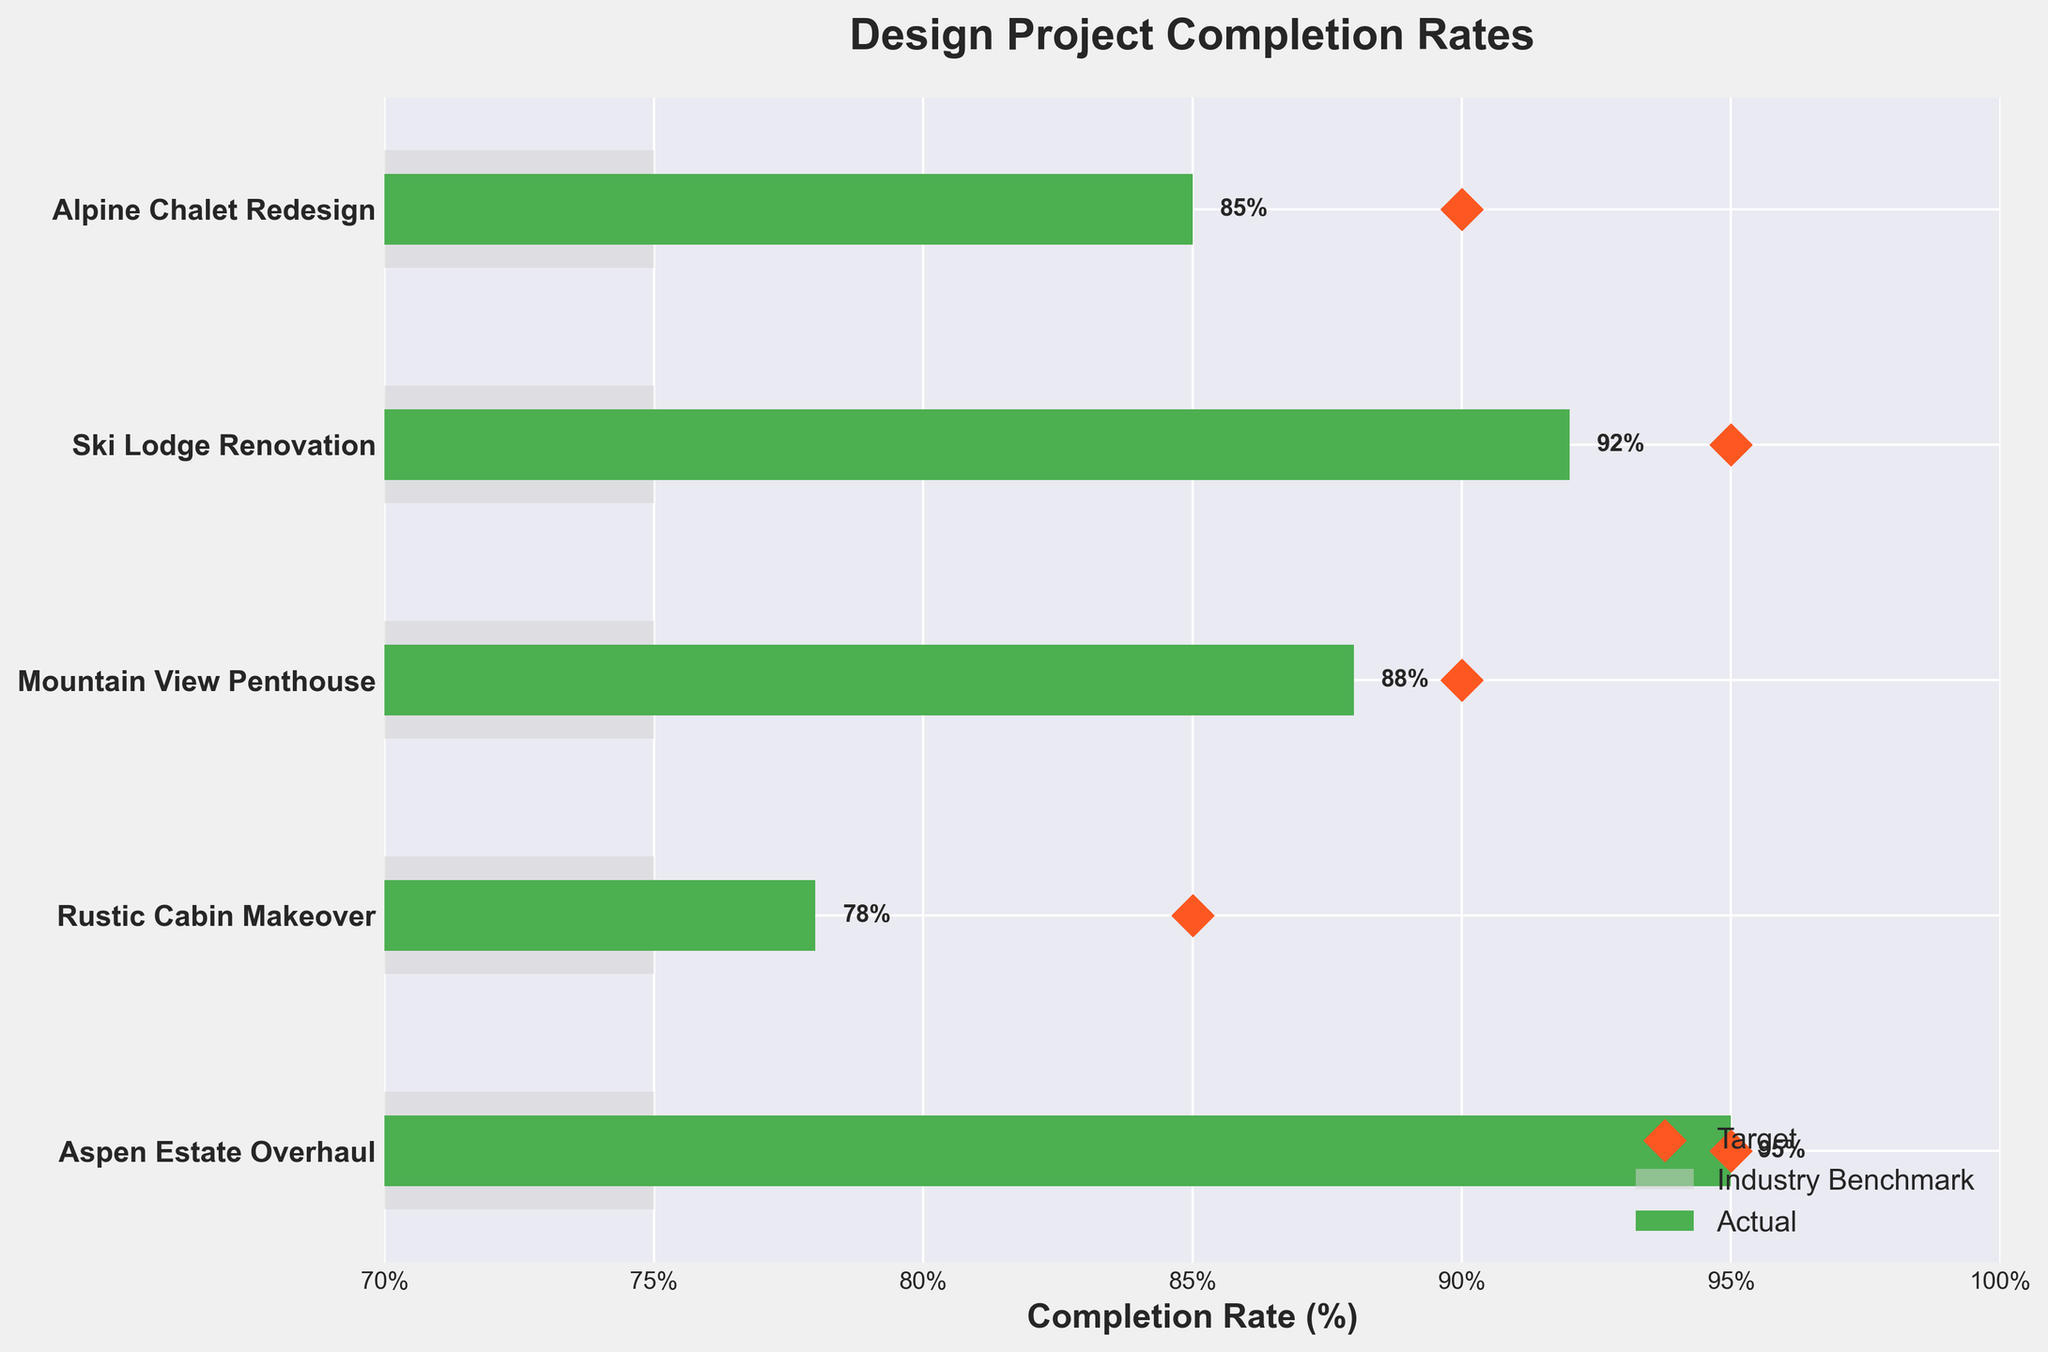What is the completion rate for the "Ski Lodge Renovation" project? The "Ski Lodge Renovation" project’s completion rate can be found from the actual values. Look for the bar corresponding to "Ski Lodge Renovation" and note its value on the x-axis.
Answer: 92% What is the target completion rate for the "Rustic Cabin Makeover" project? The target completion rates are represented by the diamond markers in the figure. Find the diamond associated with the "Rustic Cabin Makeover" project and observe its value on the x-axis.
Answer: 85% Which project has the lowest actual completion rate? To determine the project with the lowest actual completion rate, identify the shortest green bar among all the projects.
Answer: Rustic Cabin Makeover Out of the five projects, how many exceeded the industry benchmark? Compare the lengths of the green bars (actual completion rates) to the light gray bars (industry benchmarks) for each project. Count how many green bars are longer than the light gray bars.
Answer: 5 What is the difference between the actual and target completion rates for the "Mountain View Penthouse" project? Identify the actual and target values for "Mountain View Penthouse". Subtract the actual value from the target value.
Answer: 2% Which project met its target completion rate exactly? Look for a project where the diamond marker (target) aligns perfectly with the end of the green bar (actual).
Answer: Aspen Estate Overhaul Among all projects, what’s the average actual completion rate? Sum up the actual completion rates and then divide by the number of projects. (85 + 92 + 88 + 78 + 95) / 5 = 87.6%
Answer: 87.6% Which project is closest to the industry benchmark? Calculate the absolute difference between the actual completion rate and the industry benchmark for each project, and identify the project with the smallest difference. For example,
Answer: Ski Lodge Renovation How many projects have an actual completion rate greater than 90%? Count the number of green bars (actual completion rates) that are longer than the 90% mark on the x-axis.
Answer: 2 